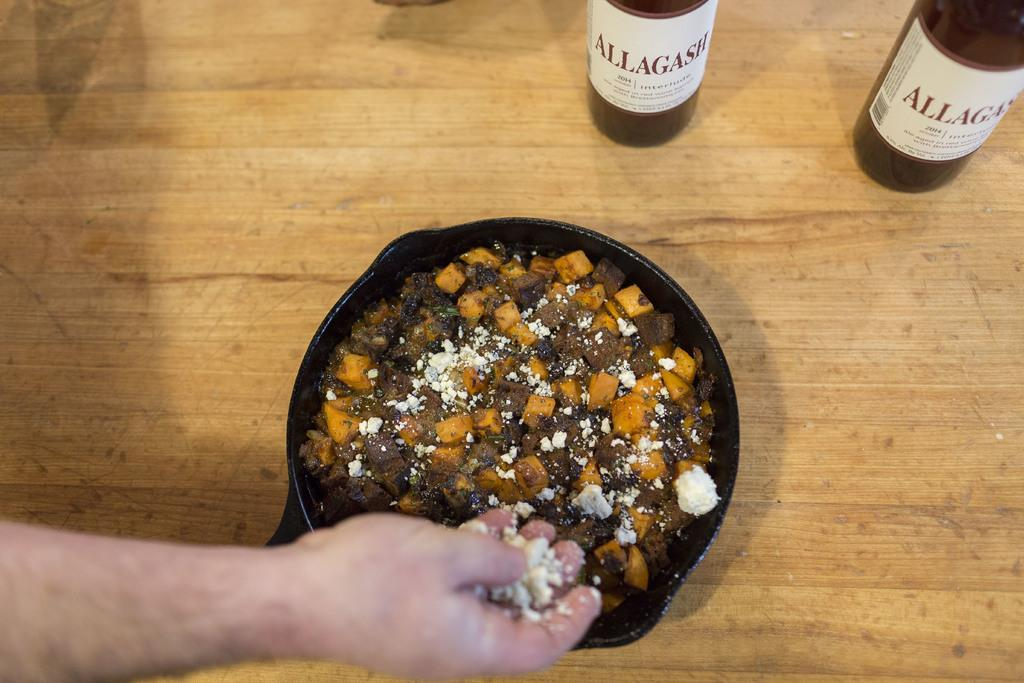<image>
Offer a succinct explanation of the picture presented. hand putting crumbled cheese on skillet of food and 2 bottles of allagash also on the table 